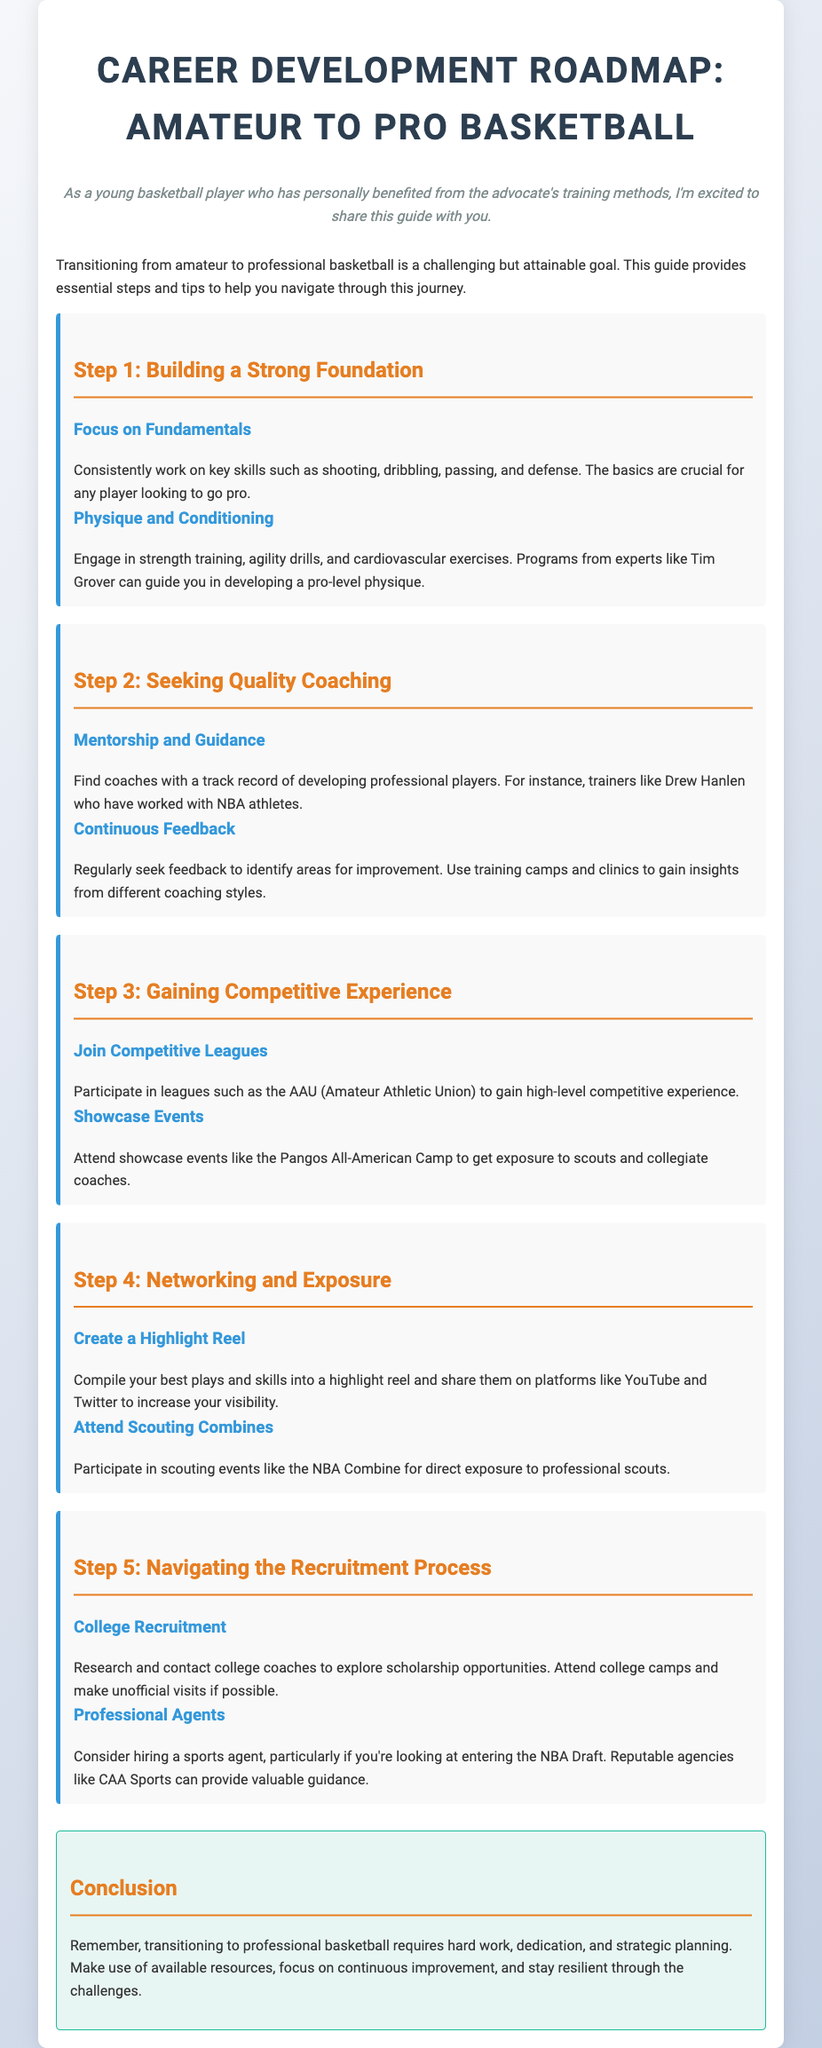what is the title of the guide? The title of the guide is explicitly stated at the beginning of the document.
Answer: Career Development Roadmap: Amateur to Pro Basketball who is mentioned as an expert in physique training? The document names a specific expert known for his training methods.
Answer: Tim Grover what is a suggested league to join for experience? The guide recommends participating in a specific league for higher competition.
Answer: AAU (Amateur Athletic Union) what type of reel should you create to increase visibility? The document suggests a specific type of media to showcase skills and plays.
Answer: Highlight Reel which agency is mentioned for hiring a sports agent? The guide advises considering a reputable agency for professional representation.
Answer: CAA Sports how many steps are outlined in the roadmap? The document lists a specific number of steps to follow for career development.
Answer: Five what is the focus of Step 1 in the guide? The first step emphasizes critical skills and physical fitness for players.
Answer: Building a Strong Foundation what event is suggested for exposure to scouts? The guide mentions a specific event for getting noticed by professional scouts.
Answer: NBA Combine 